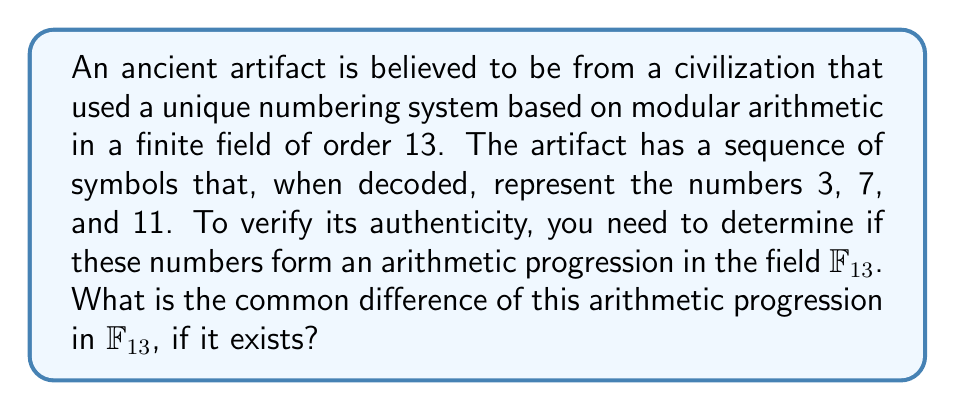Could you help me with this problem? Let's approach this step-by-step:

1) In a finite field $\mathbb{F}_{13}$, all arithmetic is performed modulo 13.

2) For three numbers $a$, $b$, and $c$ to form an arithmetic progression, the difference between consecutive terms should be constant. In other words:

   $b - a \equiv c - b \pmod{13}$

3) In our case, $a = 3$, $b = 7$, and $c = 11$.

4) Let's calculate the differences:
   
   $7 - 3 = 4$
   $11 - 7 = 4$

5) We see that $4 \equiv 4 \pmod{13}$, so these numbers do form an arithmetic progression in $\mathbb{F}_{13}$.

6) The common difference is 4.

7) We can verify this:
   
   $3 + 4 \equiv 7 \pmod{13}$
   $7 + 4 \equiv 11 \pmod{13}$

Therefore, the common difference of the arithmetic progression in $\mathbb{F}_{13}$ is 4.
Answer: 4 